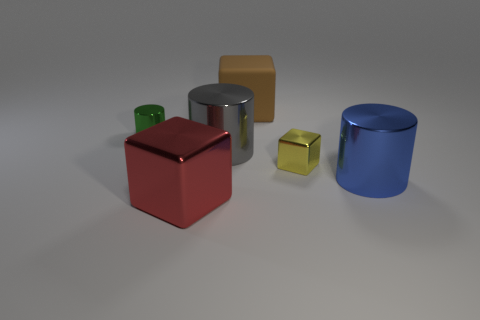What number of other objects are there of the same material as the big blue thing?
Give a very brief answer. 4. How big is the object that is both to the left of the large brown block and behind the large gray metal cylinder?
Ensure brevity in your answer.  Small. What shape is the blue object to the right of the tiny metallic thing in front of the tiny green metal cylinder?
Provide a succinct answer. Cylinder. Is there any other thing that has the same shape as the rubber object?
Ensure brevity in your answer.  Yes. Are there the same number of red objects in front of the large red metal thing and shiny blocks?
Give a very brief answer. No. There is a small block; is it the same color as the large thing in front of the big blue thing?
Make the answer very short. No. What color is the shiny object that is left of the big gray cylinder and in front of the yellow object?
Provide a succinct answer. Red. How many shiny things are on the right side of the large cylinder behind the tiny cube?
Your answer should be compact. 2. Is there a red object of the same shape as the brown thing?
Your answer should be compact. Yes. Are there the same number of tiny shiny cubes and tiny brown rubber cylinders?
Offer a terse response. No. 